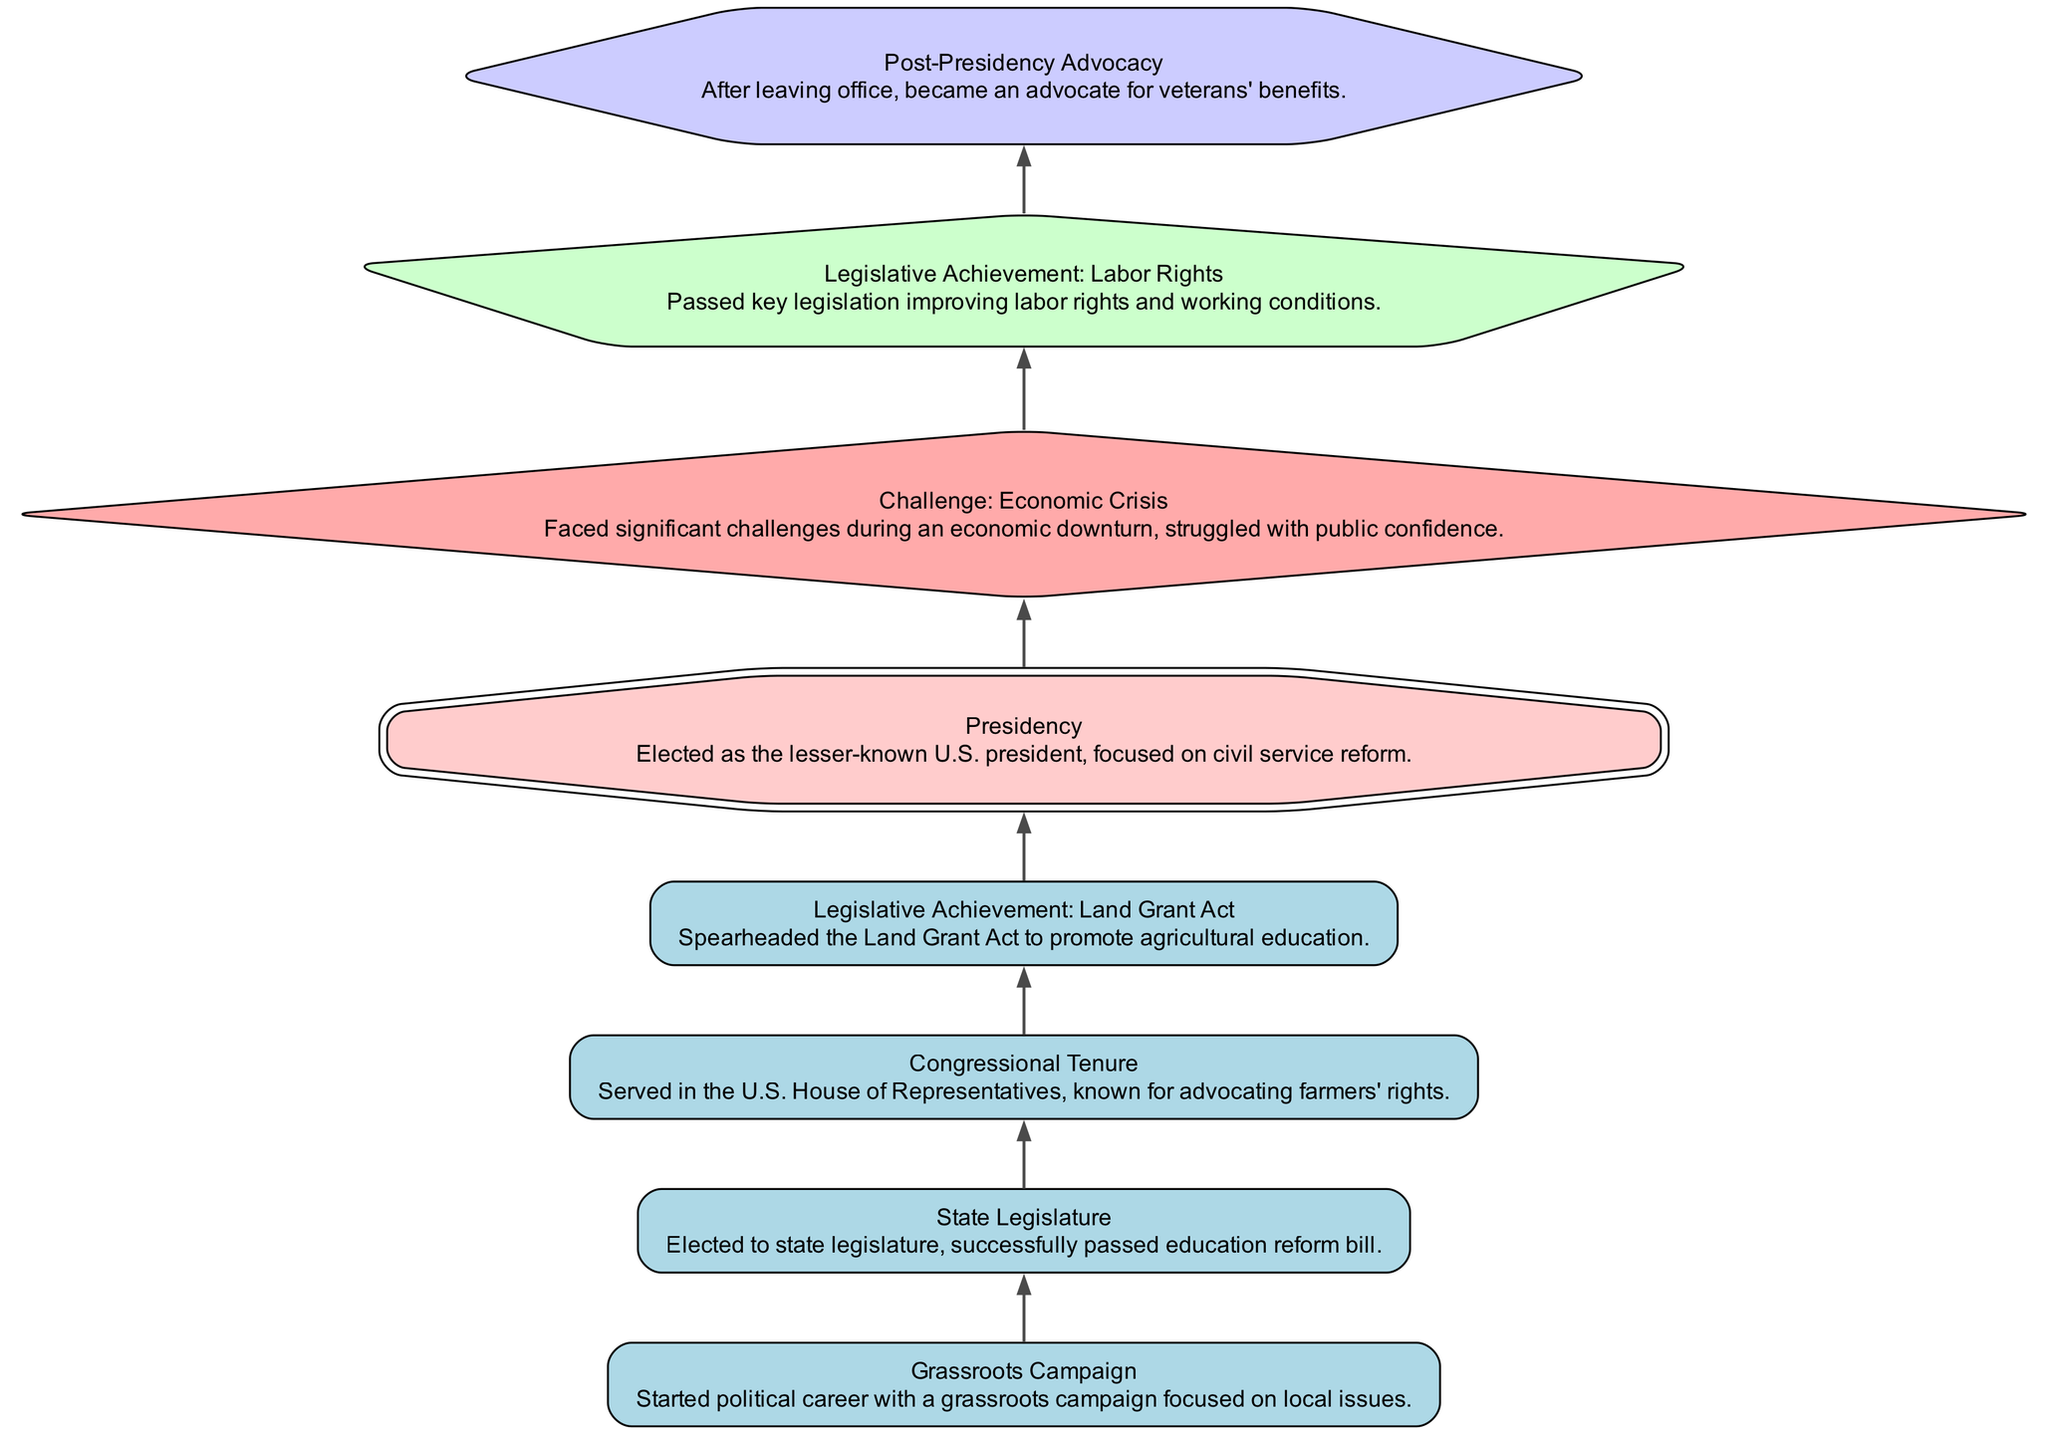What is the first step in the political career trajectory? The first node in the diagram represents the starting point of the political career, which is the "Grassroots Campaign."
Answer: Grassroots Campaign How many legislative achievements are highlighted in the diagram? By counting the nodes labeled as "Legislative Achievement," we find that there are two such nodes listed - one for the "Land Grant Act" and another for "Labor Rights."
Answer: 2 What was the key focus of the presidency node? The presidency node states the focus as "civil service reform," which is explicitly mentioned in its description.
Answer: Civil service reform Which node indicates a significant challenge faced by the president? The node marked with a diamond shape signifies the challenge faced, which is labeled "Challenge: Economic Crisis."
Answer: Challenge: Economic Crisis What is the relationship between the state legislature and congressional tenure nodes? The state legislature leads to the congressional tenure as a direct progression in the political career path; the diagram shows that after being elected to the state legislature, the individual served in the U.S. House of Representatives.
Answer: Elected to state legislature leads to congressional tenure What unique shape is used to represent the presidency in the diagram? The presidency is highlighted with a doubleoctagon shape, which distinguishes it from other nodes in the diagram, making it visually prominent.
Answer: Doubleoctagon How does the post-presidency advocacy reflect the president's ongoing commitment? After leaving office, the advocacy for veterans' benefits showcases the president's continued commitment to social issues, connecting back to the earlier focus on rights and reform.
Answer: Ongoing commitment to veterans' benefits What was the result of the "Legislative Achievement: Labor Rights"? This node outlines that significant legislation was passed to improve labor rights and working conditions, emphasizing the impact of this achievement in the context of worker rights.
Answer: Improvement in labor rights Which node appears after the presidency in the flow chart? The flow chart progresses from the presidency to the "Challenge: Economic Crisis" node, indicating the challenge faced during or after the presidential term.
Answer: Challenge: Economic Crisis 